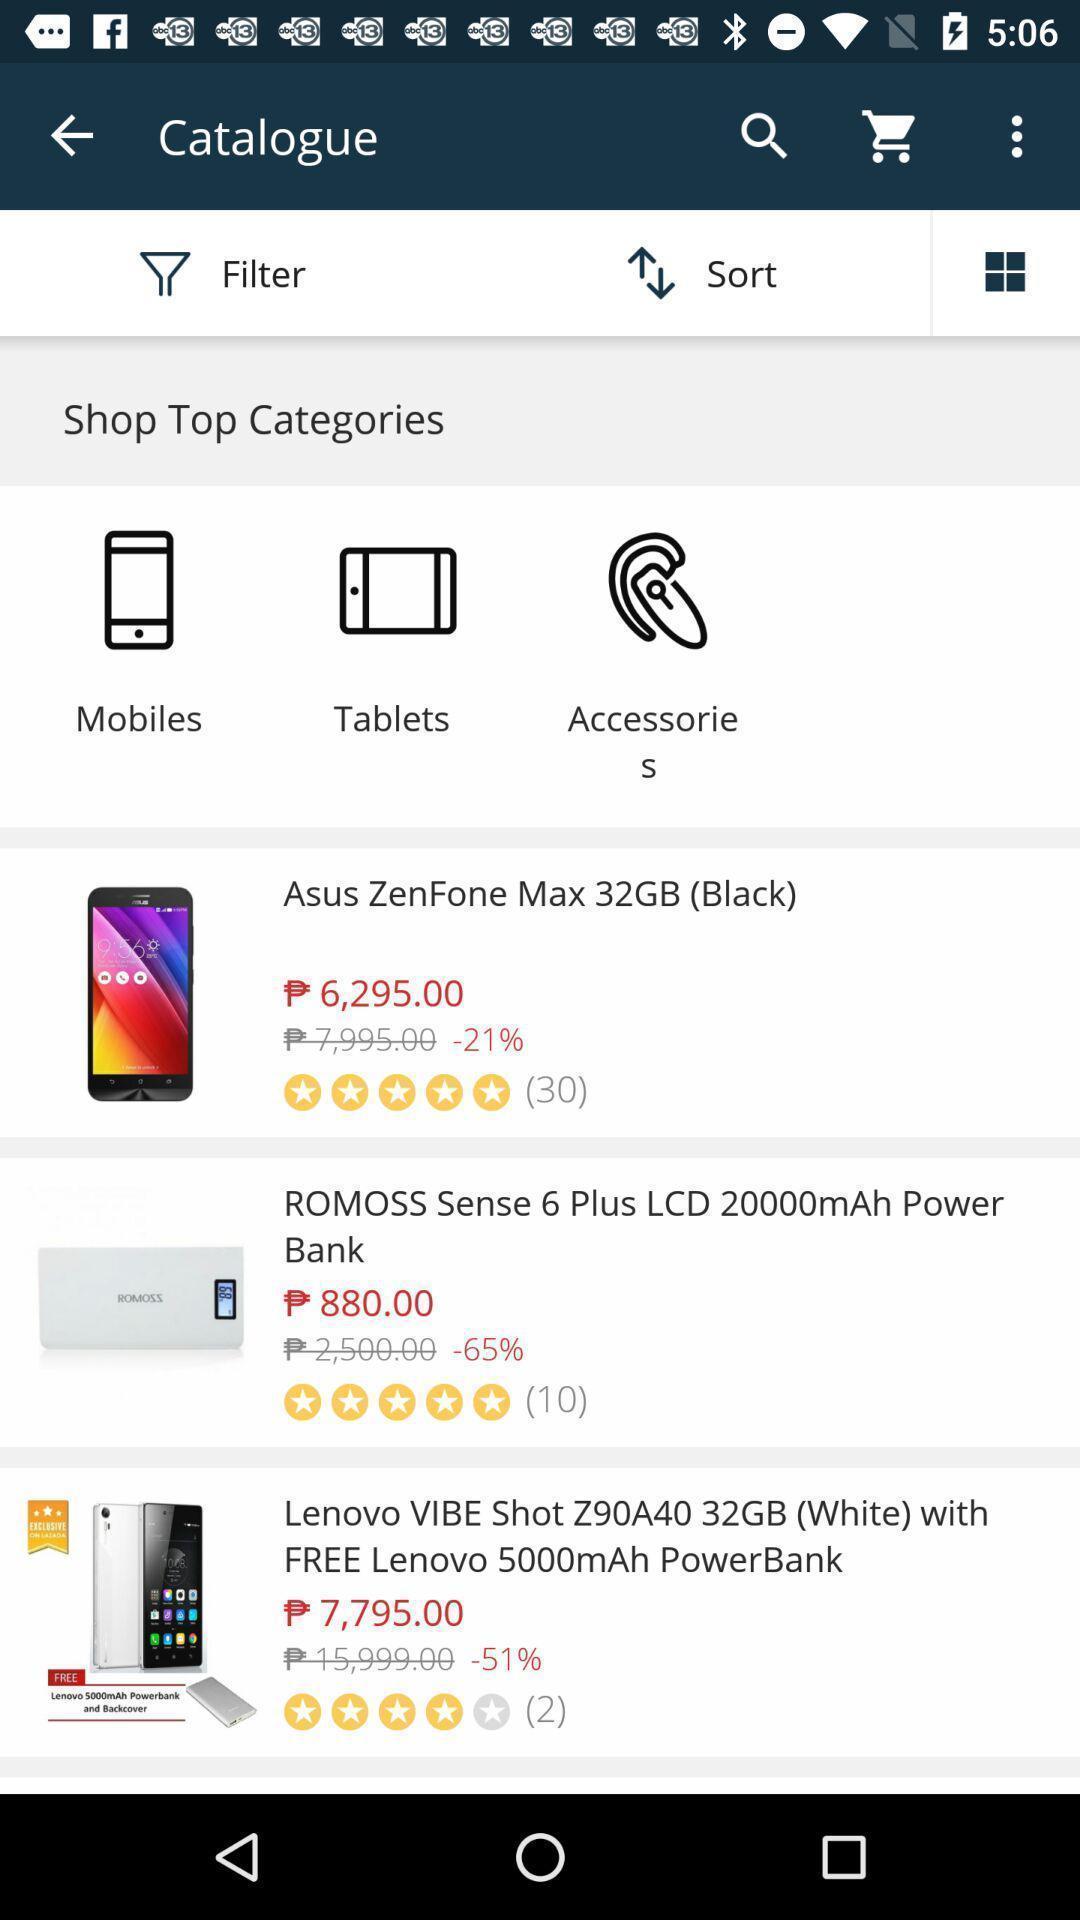Describe the visual elements of this screenshot. Shopping application displayed catalogue of items and other options. 